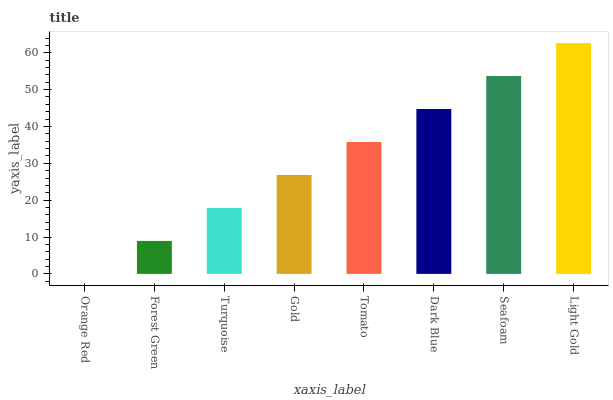Is Orange Red the minimum?
Answer yes or no. Yes. Is Light Gold the maximum?
Answer yes or no. Yes. Is Forest Green the minimum?
Answer yes or no. No. Is Forest Green the maximum?
Answer yes or no. No. Is Forest Green greater than Orange Red?
Answer yes or no. Yes. Is Orange Red less than Forest Green?
Answer yes or no. Yes. Is Orange Red greater than Forest Green?
Answer yes or no. No. Is Forest Green less than Orange Red?
Answer yes or no. No. Is Tomato the high median?
Answer yes or no. Yes. Is Gold the low median?
Answer yes or no. Yes. Is Light Gold the high median?
Answer yes or no. No. Is Tomato the low median?
Answer yes or no. No. 